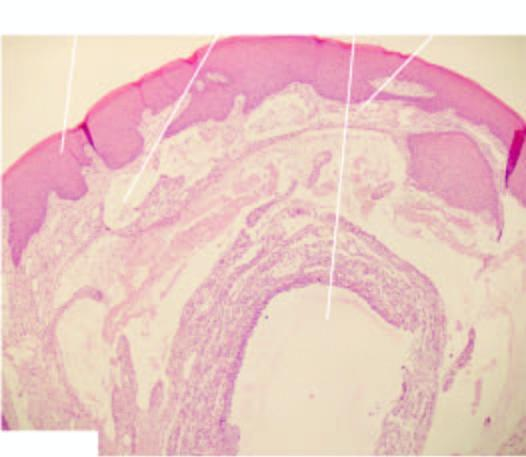s ziehl-neelsen inflammatory reaction around extravasated mucus?
Answer the question using a single word or phrase. No 